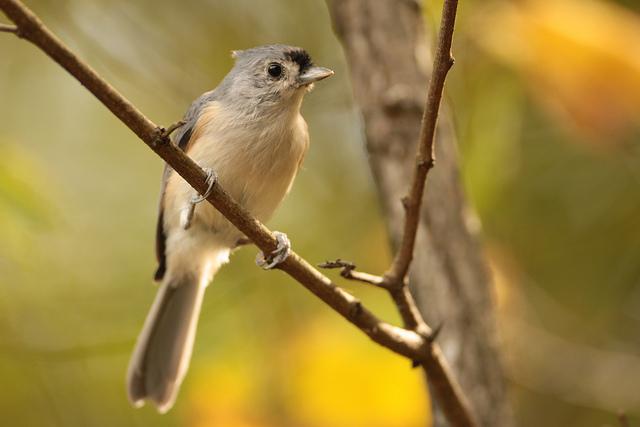What kind of bird is this?
Be succinct. Parakeet. What is the bird using to grip the branch?
Be succinct. Claws. How many birds are on the branch?
Quick response, please. 1. What kind of bird is that?
Short answer required. Finch. 